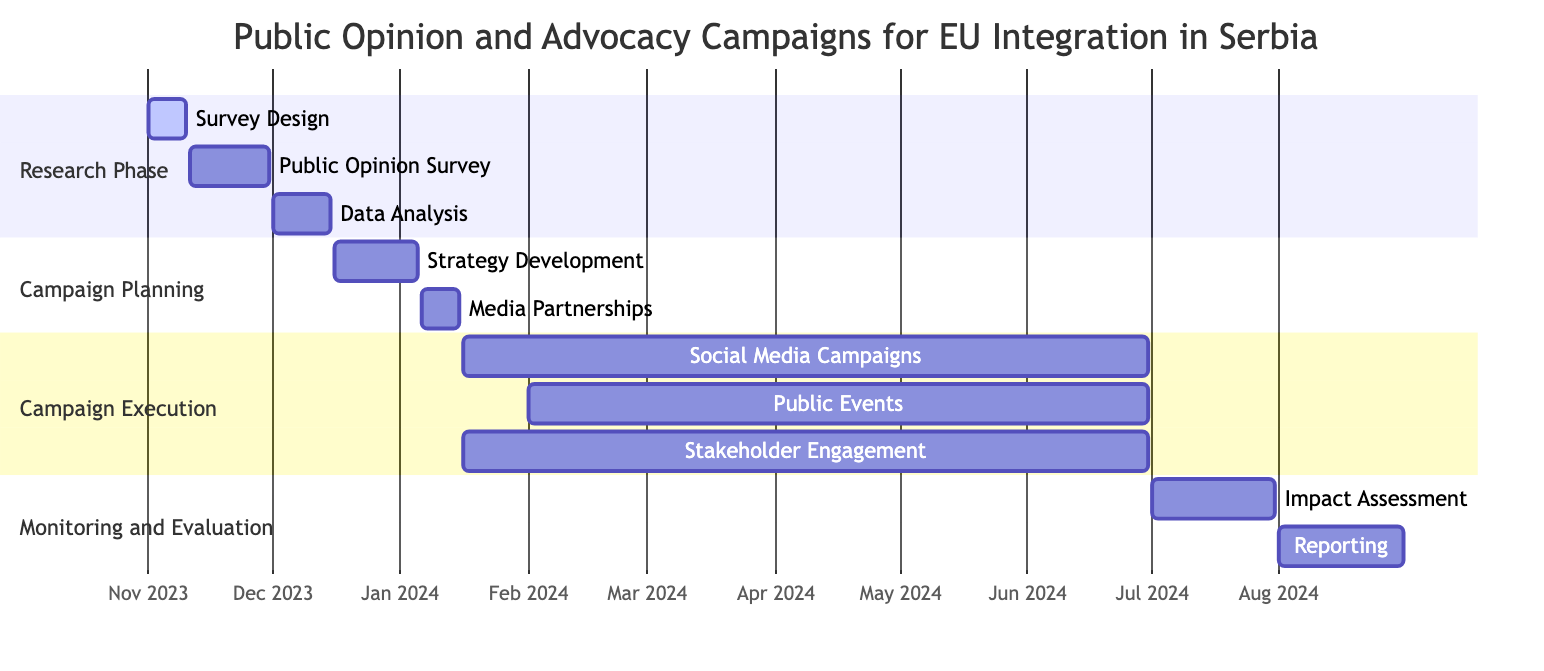What is the duration of the Research Phase? The Research Phase starts on November 1, 2023, and ends on December 15, 2023. To calculate the duration, we can simply count the days between these two dates, which is 45 days.
Answer: 45 days How many subtasks are included in the Campaign Execution section? The Campaign Execution section lists three subtasks: Social Media Campaigns, Public Events, and Stakeholder Engagement. Therefore, we can see that there are a total of three subtasks in this section.
Answer: 3 What is the start date of the Media Partnerships task? The Media Partnerships task is listed under the Campaign Planning section and starts on January 6, 2024. This information can be directly read from the diagram.
Answer: January 6, 2024 Which task overlaps with the Data Analysis subtask during December 2023? The Data Analysis subtask runs from December 1 to December 15, 2023. The Campaign Planning starts on December 16, 2023, meaning there are no overlapping tasks; hence, the task that overlaps is none.
Answer: None What is the end date for the Public Events subtask? The end date for the Public Events subtask is June 30, 2024. This is straightforward as it is clearly indicated in the diagram.
Answer: June 30, 2024 Which phase has the longest duration in the Gantt Chart? Looking through the phases, the Campaign Execution phase lasts from January 16, 2024, to June 30, 2024, which is 166 days. In contrast, the other phases are shorter. Therefore, Campaign Execution has the longest duration.
Answer: Campaign Execution What month does the Monitoring and Evaluation phase start? The Monitoring and Evaluation phase begins on July 1, 2024. This information is readily found at the start of this section in the diagram.
Answer: July How many total tasks are displayed in the Gantt Chart? The chart has four main tasks: Research Phase, Campaign Planning, Campaign Execution, and Monitoring and Evaluation. Summing these gives a total of four tasks.
Answer: 4 What are the two main subtasks in the Campaign Planning section? The Campaign Planning section has two subtasks: Strategy Development and Media Partnerships. These are directly under the Campaign Planning header and can be identified easily.
Answer: Strategy Development and Media Partnerships 